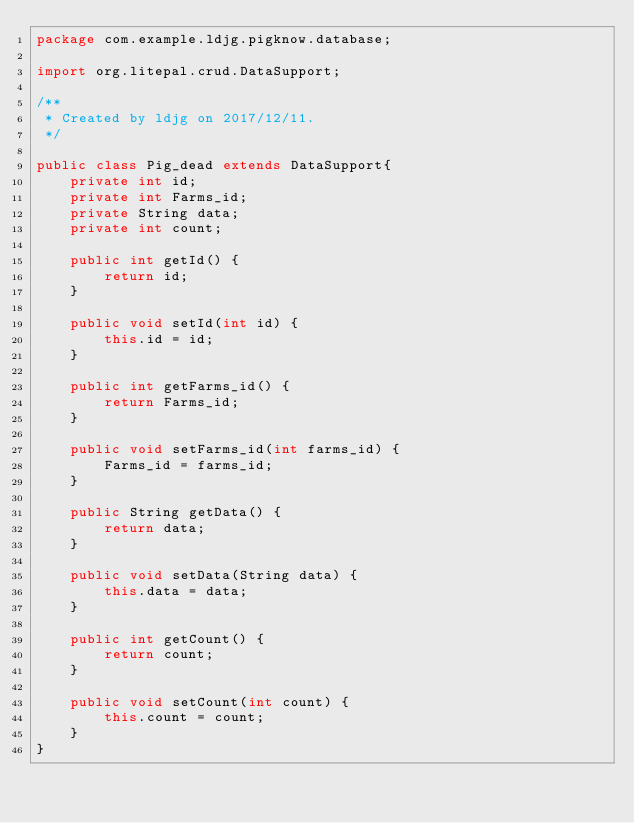Convert code to text. <code><loc_0><loc_0><loc_500><loc_500><_Java_>package com.example.ldjg.pigknow.database;

import org.litepal.crud.DataSupport;

/**
 * Created by ldjg on 2017/12/11.
 */

public class Pig_dead extends DataSupport{
    private int id;
    private int Farms_id;
    private String data;
    private int count;

    public int getId() {
        return id;
    }

    public void setId(int id) {
        this.id = id;
    }

    public int getFarms_id() {
        return Farms_id;
    }

    public void setFarms_id(int farms_id) {
        Farms_id = farms_id;
    }

    public String getData() {
        return data;
    }

    public void setData(String data) {
        this.data = data;
    }

    public int getCount() {
        return count;
    }

    public void setCount(int count) {
        this.count = count;
    }
}
</code> 